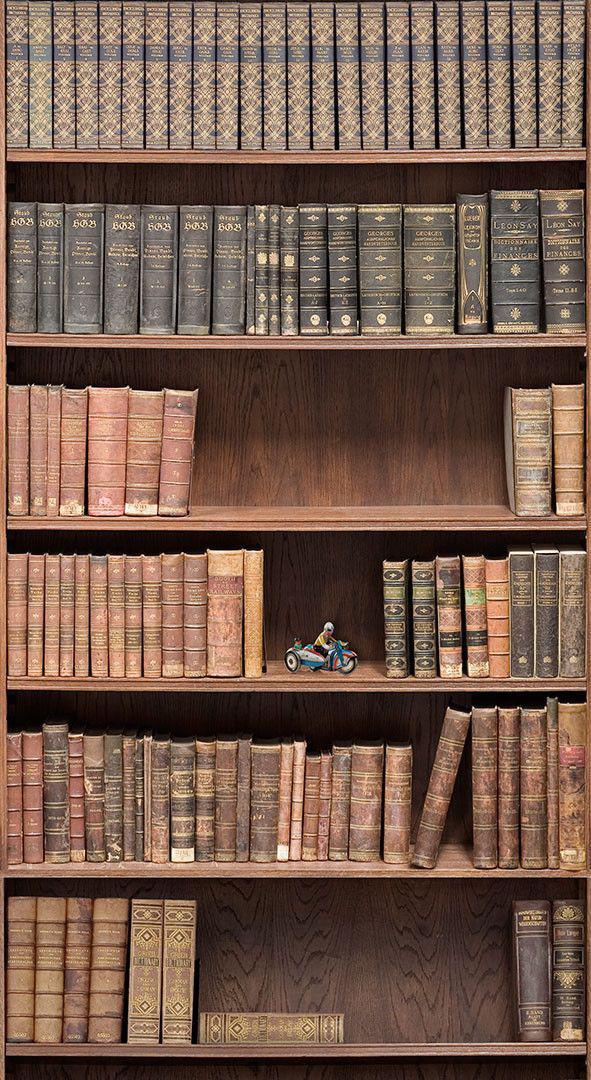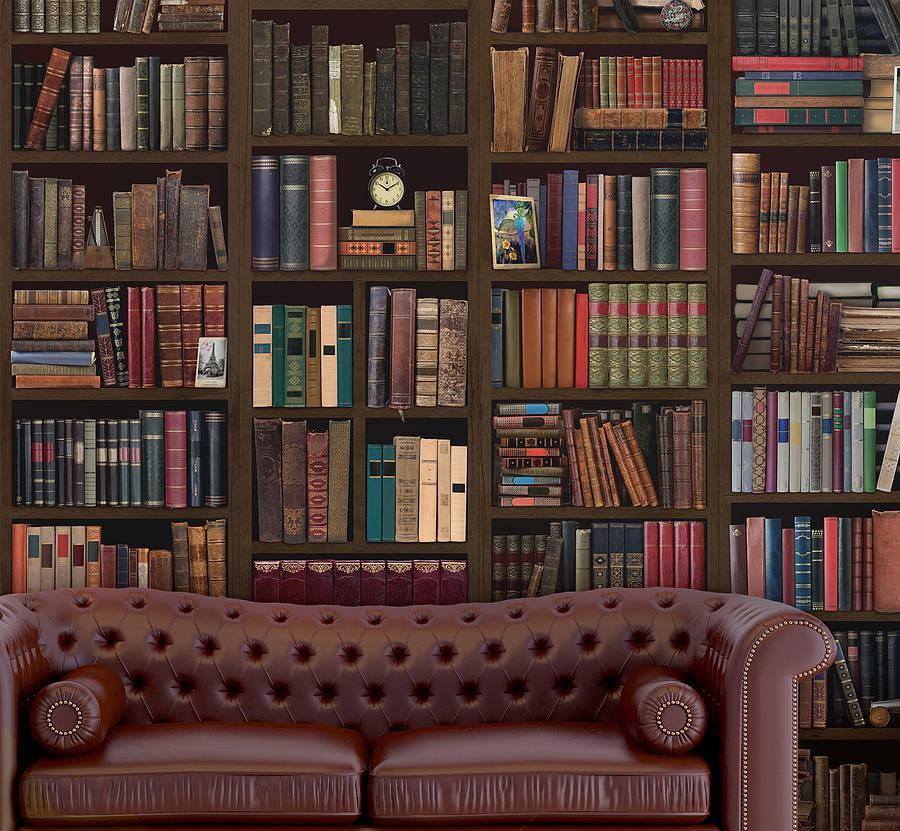The first image is the image on the left, the second image is the image on the right. Given the left and right images, does the statement "In one image there are books on a bookshelf locked up behind glass." hold true? Answer yes or no. No. The first image is the image on the left, the second image is the image on the right. For the images displayed, is the sentence "there is a room with a bookshelf made of dark wood and a leather sofa in front of it" factually correct? Answer yes or no. Yes. 